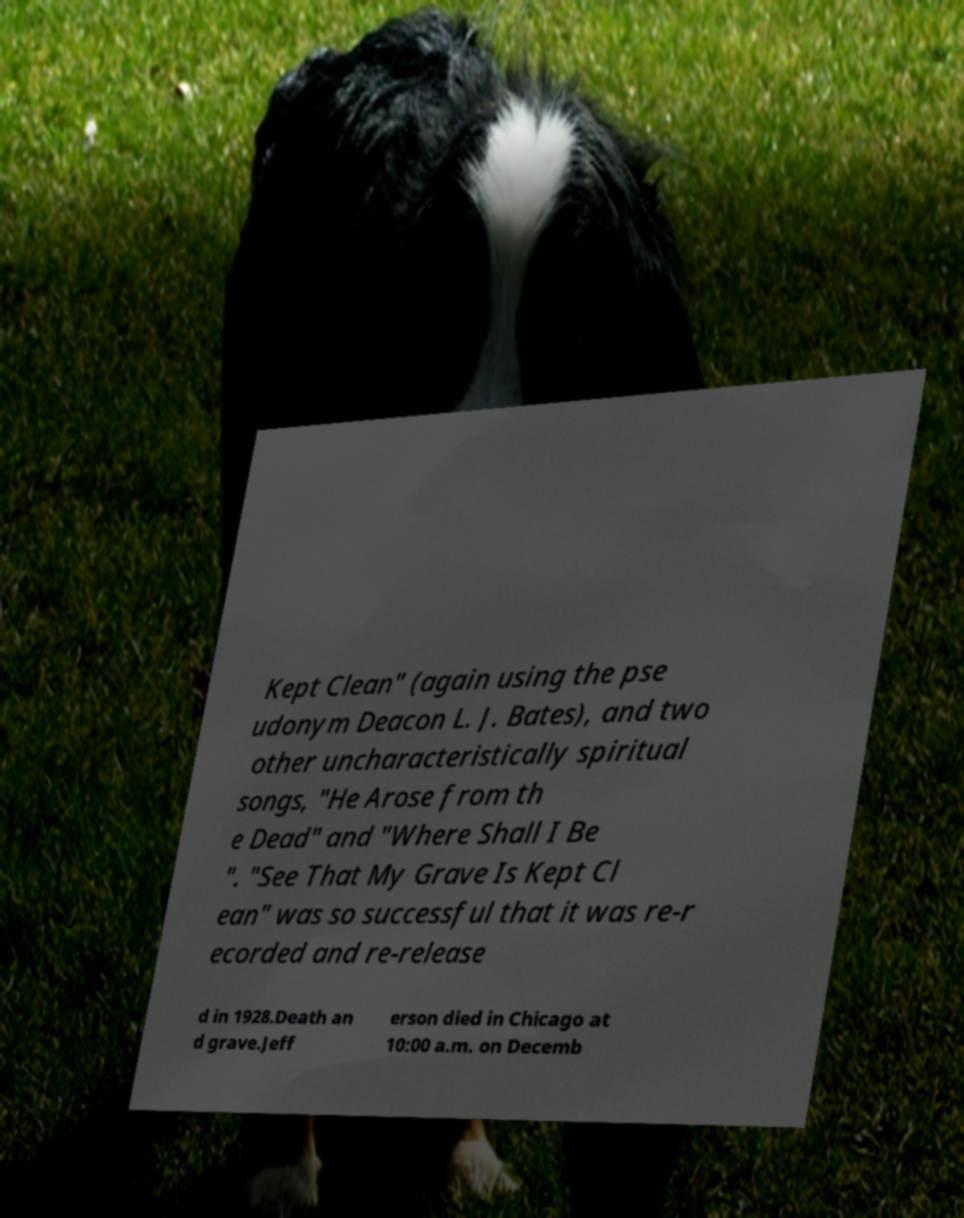Please read and relay the text visible in this image. What does it say? Kept Clean" (again using the pse udonym Deacon L. J. Bates), and two other uncharacteristically spiritual songs, "He Arose from th e Dead" and "Where Shall I Be ". "See That My Grave Is Kept Cl ean" was so successful that it was re-r ecorded and re-release d in 1928.Death an d grave.Jeff erson died in Chicago at 10:00 a.m. on Decemb 